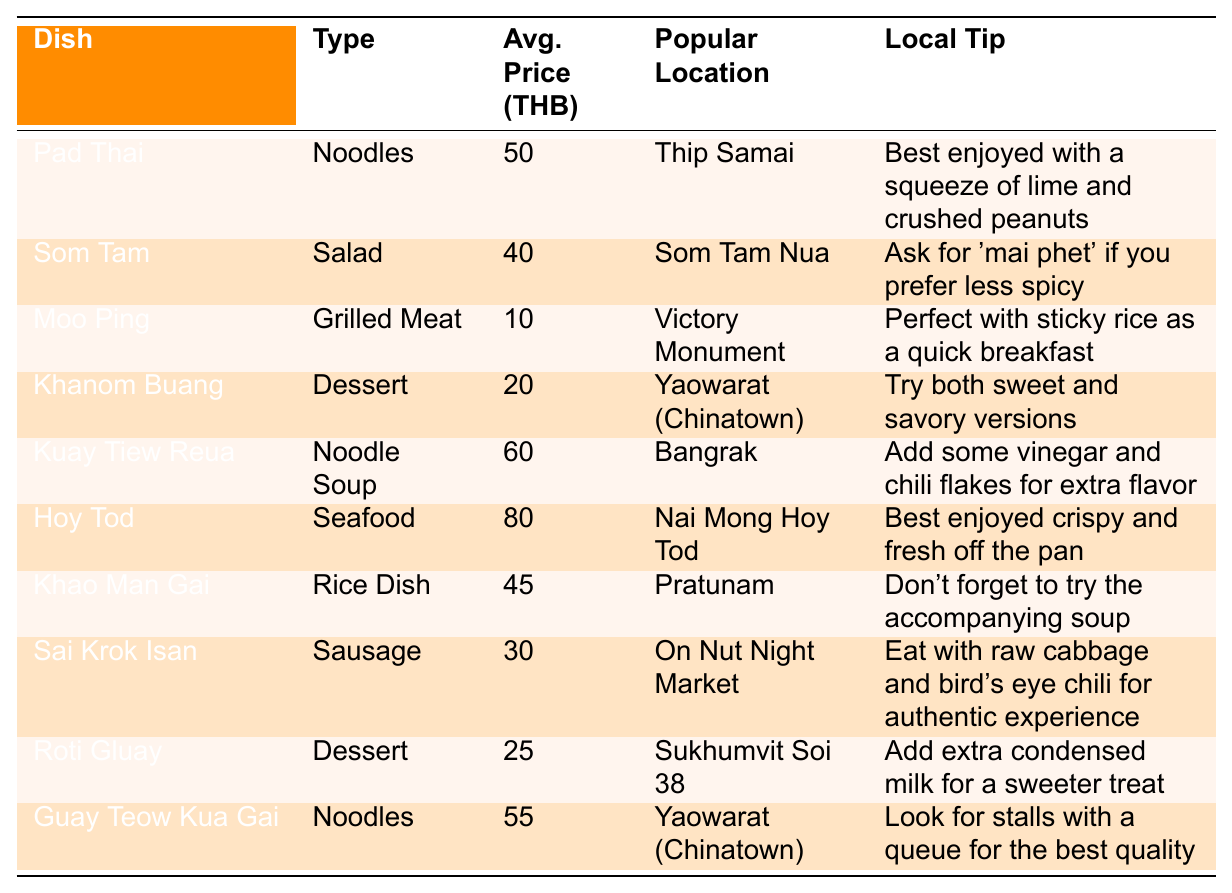What is the average price of Pad Thai? The table lists the average price for Pad Thai, which is specified as 50 THB.
Answer: 50 THB Which dish has the lowest average price? The dish with the lowest average price is Moo Ping, with an average price of 10 THB.
Answer: Moo Ping How much more expensive is Hoy Tod compared to Khao Man Gai? Hoy Tod is 80 THB and Khao Man Gai is 45 THB. The difference is 80 - 45 = 35 THB.
Answer: 35 THB What type of dish is Khanom Buang? The table categorizes Khanom Buang as a dessert.
Answer: Dessert Is Som Tam more expensive than Sai Krok Isan? Som Tam is priced at 40 THB while Sai Krok Isan is 30 THB, so Som Tam is more expensive.
Answer: Yes What is the average price of all noodle dishes? The noodle dishes are Pad Thai (50), Kuay Tiew Reua (60), and Guay Teow Kua Gai (55). The total is 50 + 60 + 55 = 165 THB. Dividing by 3 gives an average of 165 / 3 = 55 THB.
Answer: 55 THB Which dish is popular in Yaowarat (Chinatown)? The dishes listed for Yaowarat (Chinatown) are Khanom Buang and Guay Teow Kua Gai.
Answer: Khanom Buang, Guay Teow Kua Gai How many dishes are priced under 30 THB? The only dish priced under 30 THB is Moo Ping at 10 THB; thus, there is one dish.
Answer: 1 What special tip is provided for Khao Man Gai? The local tip for Khao Man Gai is to not forget to try the accompanying soup.
Answer: Try the accompanying soup Which dish could be considered the best for a quick breakfast? Moo Ping is noted as perfect with sticky rice as a quick breakfast.
Answer: Moo Ping 